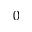<formula> <loc_0><loc_0><loc_500><loc_500>0</formula> 